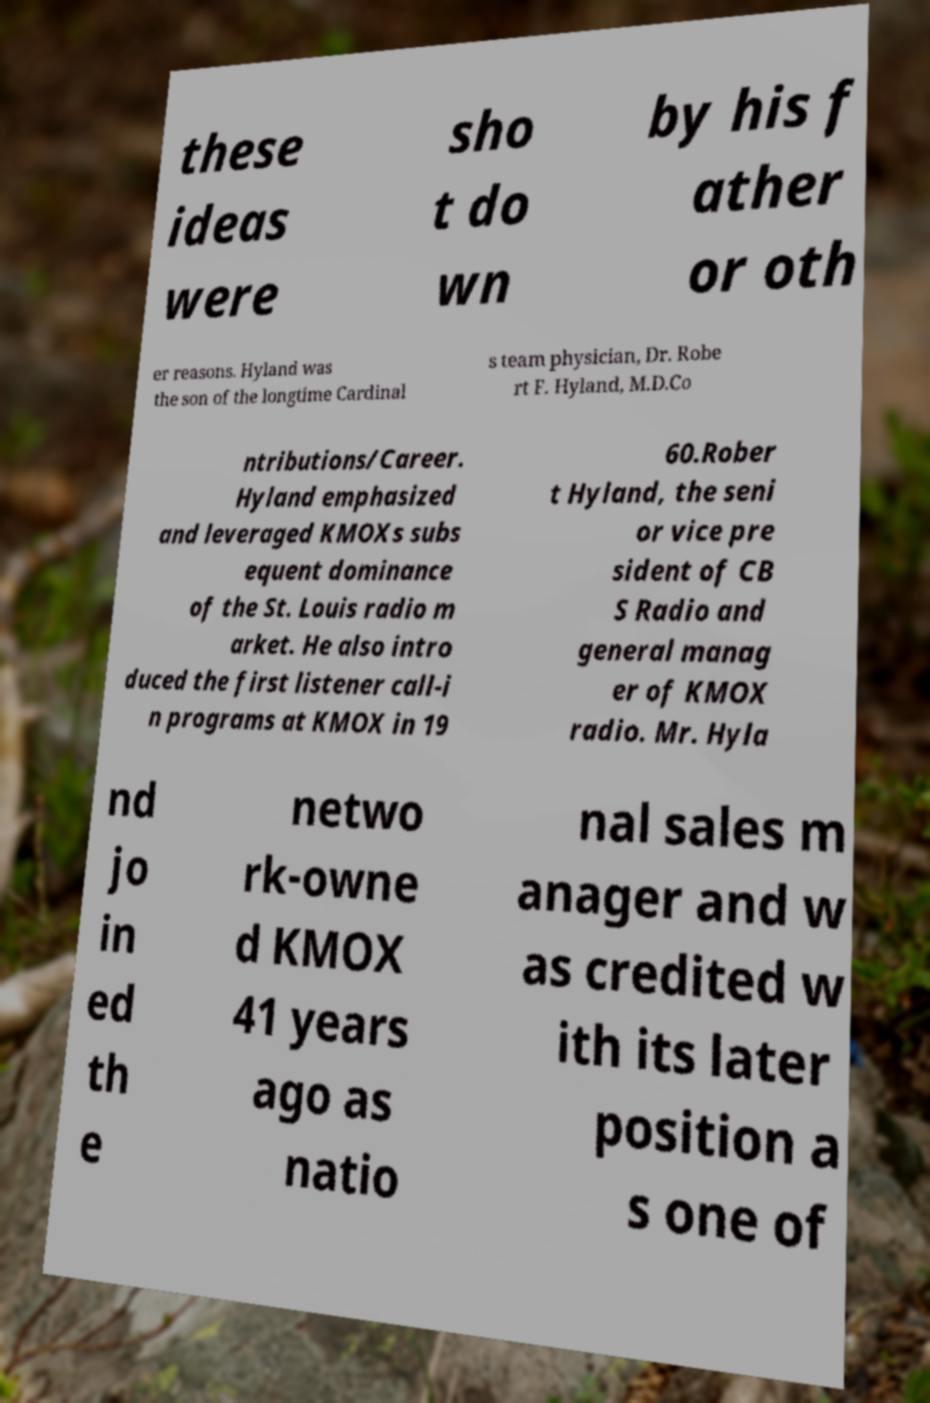Could you assist in decoding the text presented in this image and type it out clearly? these ideas were sho t do wn by his f ather or oth er reasons. Hyland was the son of the longtime Cardinal s team physician, Dr. Robe rt F. Hyland, M.D.Co ntributions/Career. Hyland emphasized and leveraged KMOXs subs equent dominance of the St. Louis radio m arket. He also intro duced the first listener call-i n programs at KMOX in 19 60.Rober t Hyland, the seni or vice pre sident of CB S Radio and general manag er of KMOX radio. Mr. Hyla nd jo in ed th e netwo rk-owne d KMOX 41 years ago as natio nal sales m anager and w as credited w ith its later position a s one of 